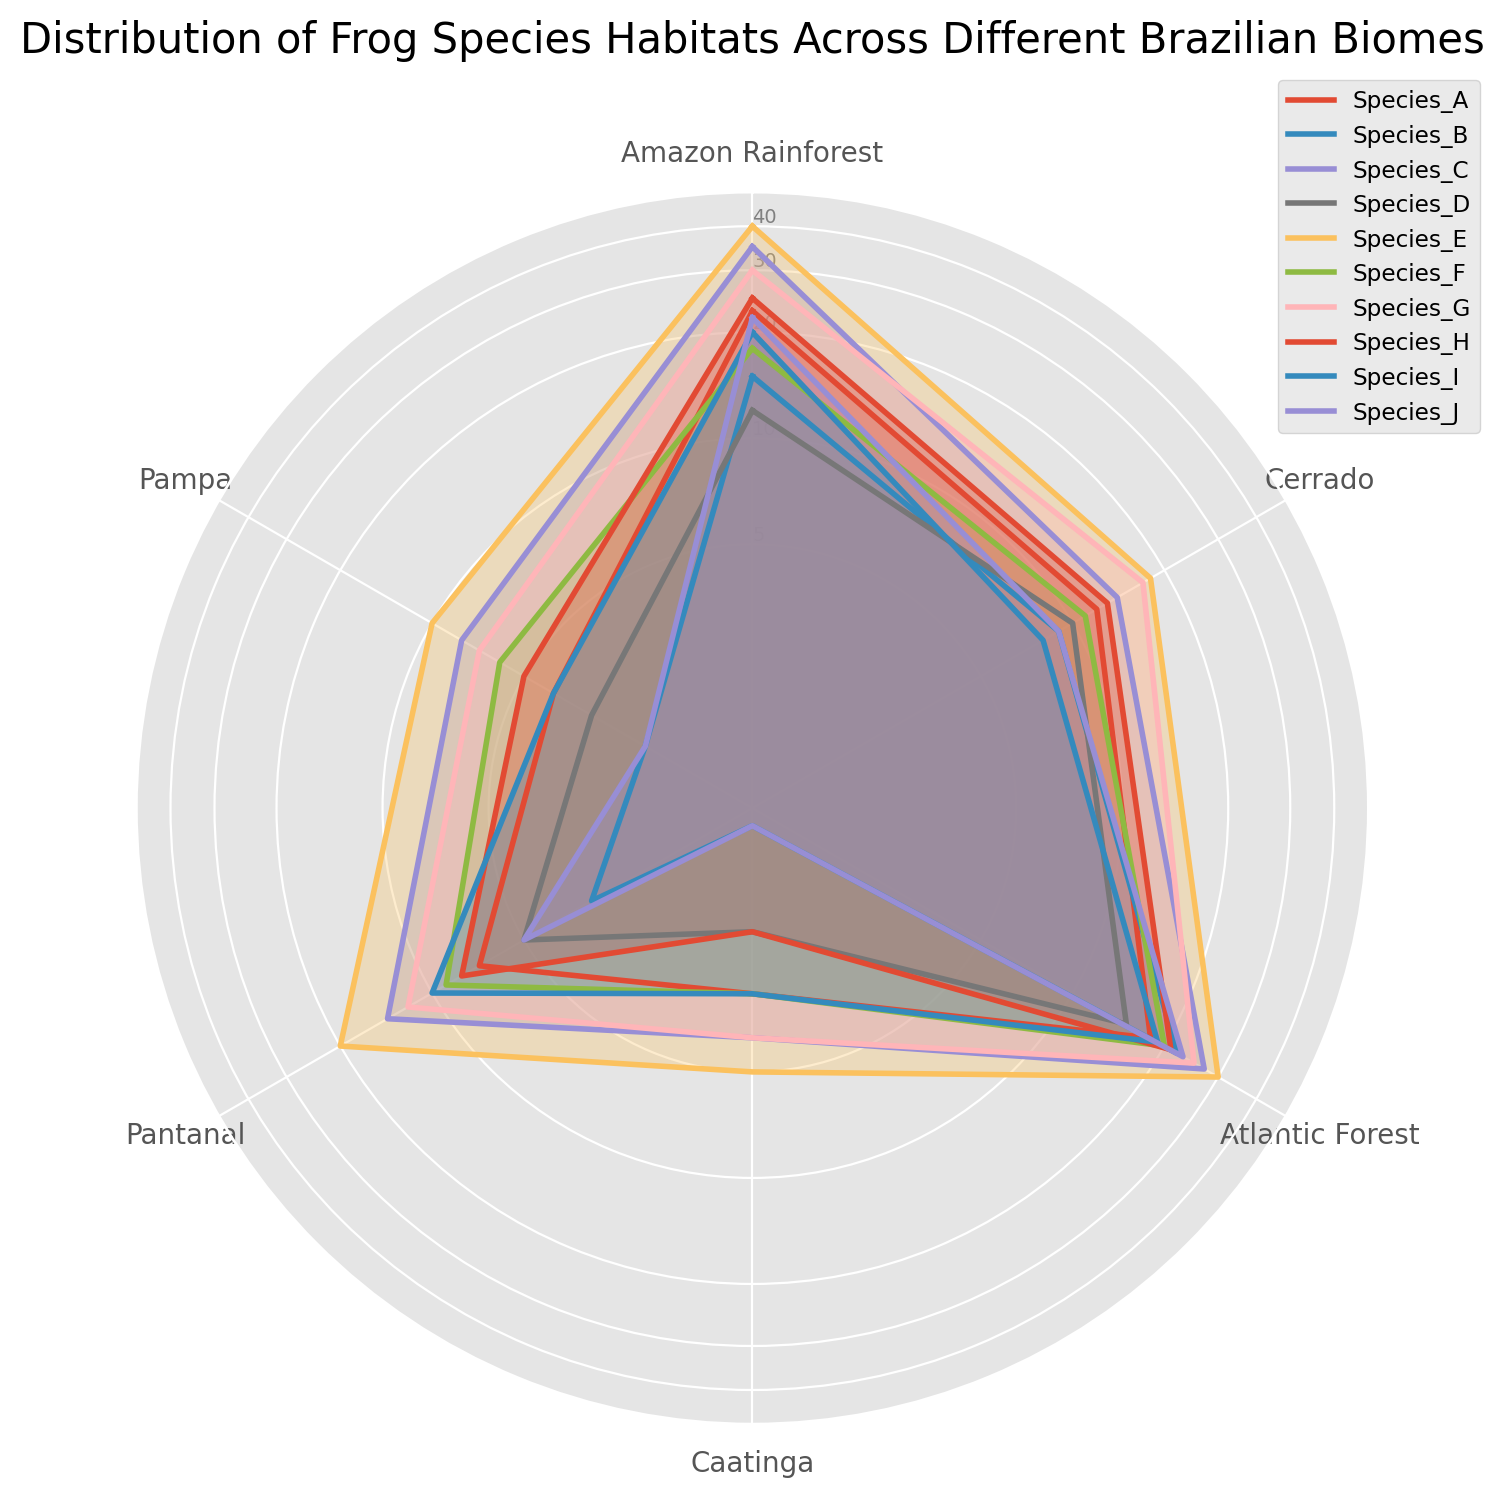Which species has the highest habitat distribution in the Amazon Rainforest? By looking at the plot line corresponding to 'Amazon Rainforest,' find the species with the highest peak.
Answer: Species E Which biome shows the most uniform distribution across all frog species? Examine the plot lines for each biome and identify the one with the least variation in distances from the center.
Answer: Cerrado Which species has the lowest habitat distribution in the Caatinga biome? Observe the plot section for Caatinga and note which species has the smallest value.
Answer: Species_B What is the difference in habitat distribution for Species G between the Amazon Rainforest and the Pampa? Locate the values for Species G in both Amazon Rainforest and Pampa and compute the difference.
Answer: 23 Which species has a higher habitat distribution in the Pantanal biome, Species A or Species F? Compare the plot points for Species A and Species F in the Pantanal section.
Answer: Species A What's the average habitat distribution of Species I across all biomes? Sum the values for each biome for Species I and divide by the number of biomes (6). (20+8+19+3+10+4)/6 = 10.67
Answer: 10.67 Which species has the widest range of habitat distribution values across all biomes? Calculate the range (max - min) for each species's habitat distribution across the biomes. The species with the highest range value is the answer.
Answer: Species E Compare the habitat distribution of Species C in the Amazon Rainforest and the Atlantic Forest. Is it higher in the Amazon Rainforest? Check the plotted values for Species C in both biomes and compare them.
Answer: No Which two species have the most similar distribution patterns across all biomes? Compare the shapes and peaks of the different species across the biomes to determine which two have the most similar patterns.
Answer: Species H and Species I 